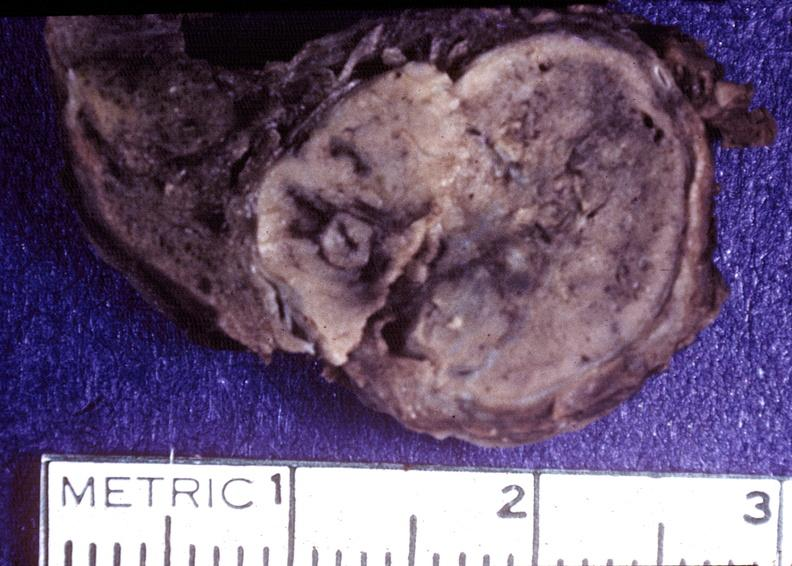does this image show thyroid, hurthle cell adenoma?
Answer the question using a single word or phrase. Yes 